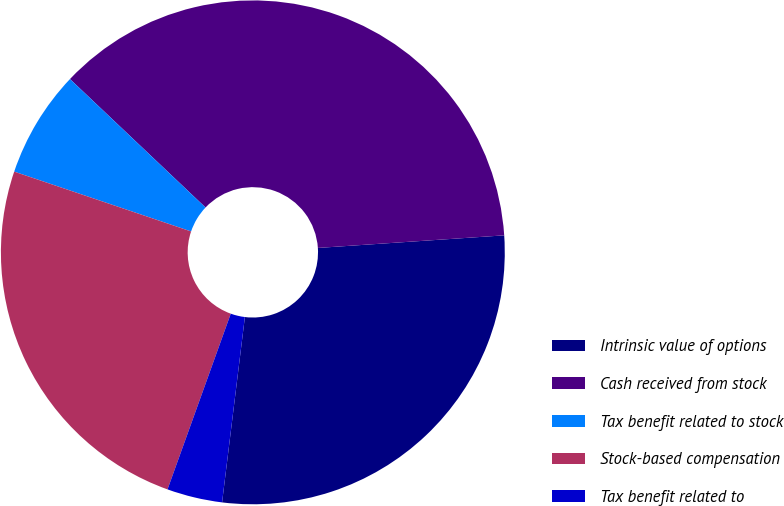Convert chart. <chart><loc_0><loc_0><loc_500><loc_500><pie_chart><fcel>Intrinsic value of options<fcel>Cash received from stock<fcel>Tax benefit related to stock<fcel>Stock-based compensation<fcel>Tax benefit related to<nl><fcel>28.02%<fcel>36.85%<fcel>6.88%<fcel>24.69%<fcel>3.55%<nl></chart> 